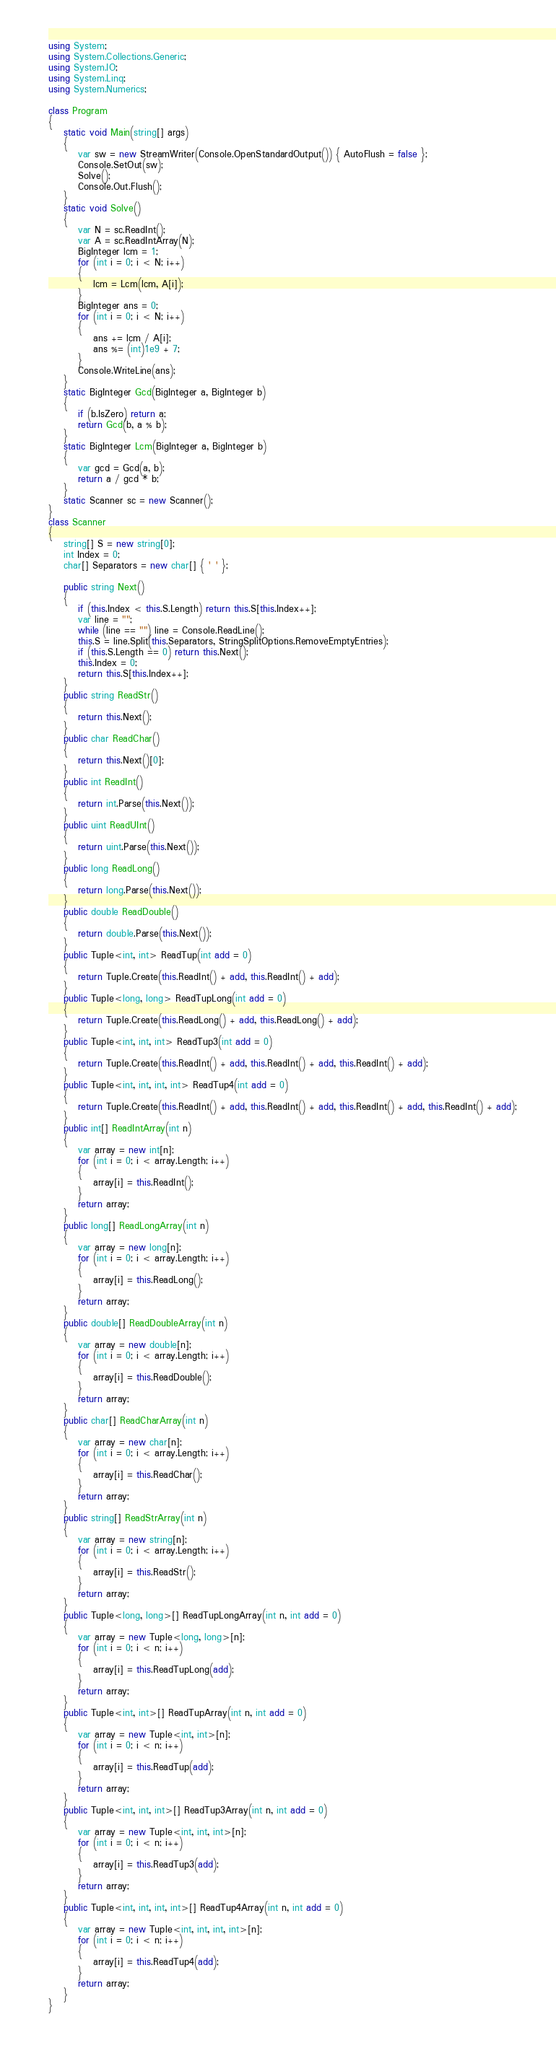<code> <loc_0><loc_0><loc_500><loc_500><_C#_>using System;
using System.Collections.Generic;
using System.IO;
using System.Linq;
using System.Numerics;

class Program
{
    static void Main(string[] args)
    {
        var sw = new StreamWriter(Console.OpenStandardOutput()) { AutoFlush = false };
        Console.SetOut(sw);
        Solve();
        Console.Out.Flush();
    }
    static void Solve()
    {
        var N = sc.ReadInt();
        var A = sc.ReadIntArray(N);
        BigInteger lcm = 1;
        for (int i = 0; i < N; i++)
        {
            lcm = Lcm(lcm, A[i]);
        }
        BigInteger ans = 0;
        for (int i = 0; i < N; i++)
        {
            ans += lcm / A[i];
            ans %= (int)1e9 + 7;
        }
        Console.WriteLine(ans);
    }
    static BigInteger Gcd(BigInteger a, BigInteger b)
    {
        if (b.IsZero) return a;
        return Gcd(b, a % b);
    }
    static BigInteger Lcm(BigInteger a, BigInteger b)
    {
        var gcd = Gcd(a, b);
        return a / gcd * b;
    }
    static Scanner sc = new Scanner();
}
class Scanner
{
    string[] S = new string[0];
    int Index = 0;
    char[] Separators = new char[] { ' ' };

    public string Next()
    {
        if (this.Index < this.S.Length) return this.S[this.Index++];
        var line = "";
        while (line == "") line = Console.ReadLine();
        this.S = line.Split(this.Separators, StringSplitOptions.RemoveEmptyEntries);
        if (this.S.Length == 0) return this.Next();
        this.Index = 0;
        return this.S[this.Index++];
    }
    public string ReadStr()
    {
        return this.Next();
    }
    public char ReadChar()
    {
        return this.Next()[0];
    }
    public int ReadInt()
    {
        return int.Parse(this.Next());
    }
    public uint ReadUInt()
    {
        return uint.Parse(this.Next());
    }
    public long ReadLong()
    {
        return long.Parse(this.Next());
    }
    public double ReadDouble()
    {
        return double.Parse(this.Next());
    }
    public Tuple<int, int> ReadTup(int add = 0)
    {
        return Tuple.Create(this.ReadInt() + add, this.ReadInt() + add);
    }
    public Tuple<long, long> ReadTupLong(int add = 0)
    {
        return Tuple.Create(this.ReadLong() + add, this.ReadLong() + add);
    }
    public Tuple<int, int, int> ReadTup3(int add = 0)
    {
        return Tuple.Create(this.ReadInt() + add, this.ReadInt() + add, this.ReadInt() + add);
    }
    public Tuple<int, int, int, int> ReadTup4(int add = 0)
    {
        return Tuple.Create(this.ReadInt() + add, this.ReadInt() + add, this.ReadInt() + add, this.ReadInt() + add);
    }
    public int[] ReadIntArray(int n)
    {
        var array = new int[n];
        for (int i = 0; i < array.Length; i++)
        {
            array[i] = this.ReadInt();
        }
        return array;
    }
    public long[] ReadLongArray(int n)
    {
        var array = new long[n];
        for (int i = 0; i < array.Length; i++)
        {
            array[i] = this.ReadLong();
        }
        return array;
    }
    public double[] ReadDoubleArray(int n)
    {
        var array = new double[n];
        for (int i = 0; i < array.Length; i++)
        {
            array[i] = this.ReadDouble();
        }
        return array;
    }
    public char[] ReadCharArray(int n)
    {
        var array = new char[n];
        for (int i = 0; i < array.Length; i++)
        {
            array[i] = this.ReadChar();
        }
        return array;
    }
    public string[] ReadStrArray(int n)
    {
        var array = new string[n];
        for (int i = 0; i < array.Length; i++)
        {
            array[i] = this.ReadStr();
        }
        return array;
    }
    public Tuple<long, long>[] ReadTupLongArray(int n, int add = 0)
    {
        var array = new Tuple<long, long>[n];
        for (int i = 0; i < n; i++)
        {
            array[i] = this.ReadTupLong(add);
        }
        return array;
    }
    public Tuple<int, int>[] ReadTupArray(int n, int add = 0)
    {
        var array = new Tuple<int, int>[n];
        for (int i = 0; i < n; i++)
        {
            array[i] = this.ReadTup(add);
        }
        return array;
    }
    public Tuple<int, int, int>[] ReadTup3Array(int n, int add = 0)
    {
        var array = new Tuple<int, int, int>[n];
        for (int i = 0; i < n; i++)
        {
            array[i] = this.ReadTup3(add);
        }
        return array;
    }
    public Tuple<int, int, int, int>[] ReadTup4Array(int n, int add = 0)
    {
        var array = new Tuple<int, int, int, int>[n];
        for (int i = 0; i < n; i++)
        {
            array[i] = this.ReadTup4(add);
        }
        return array;
    }
}
</code> 